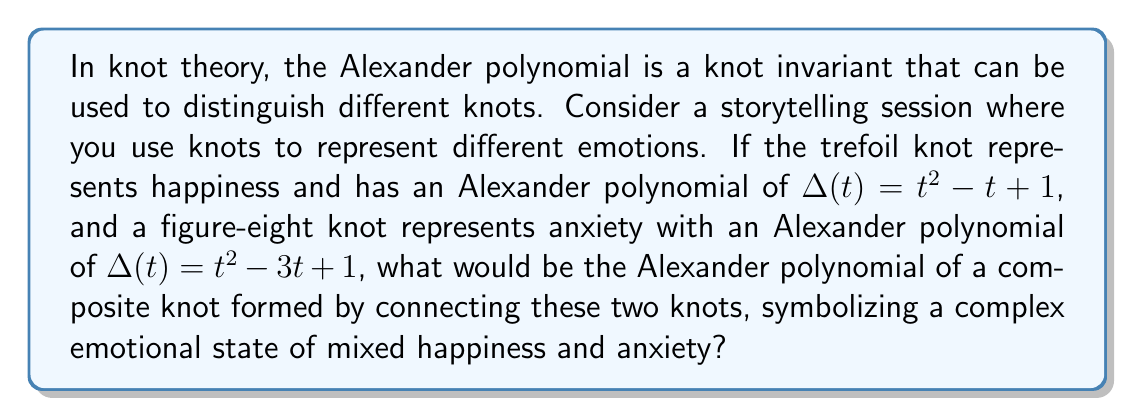Could you help me with this problem? To solve this problem, we need to follow these steps:

1. Recall that for a composite knot formed by connecting two knots, the Alexander polynomial is the product of the individual polynomials.

2. Let's denote the Alexander polynomial of the trefoil knot (happiness) as $\Delta_1(t)$ and the figure-eight knot (anxiety) as $\Delta_2(t)$:

   $\Delta_1(t) = t^2 - t + 1$ (trefoil knot)
   $\Delta_2(t) = t^2 - 3t + 1$ (figure-eight knot)

3. The Alexander polynomial of the composite knot, $\Delta_c(t)$, is:

   $\Delta_c(t) = \Delta_1(t) \cdot \Delta_2(t)$

4. Multiply the polynomials:

   $\Delta_c(t) = (t^2 - t + 1)(t^2 - 3t + 1)$

5. Expand the product:

   $\Delta_c(t) = t^4 - 3t^3 + t^2 - t^3 + 3t^2 - t + t^2 - 3t + 1$

6. Combine like terms:

   $\Delta_c(t) = t^4 - 4t^3 + 5t^2 - 4t + 1$

This final polynomial represents the Alexander polynomial of the composite knot symbolizing the complex emotional state of mixed happiness and anxiety.
Answer: $t^4 - 4t^3 + 5t^2 - 4t + 1$ 